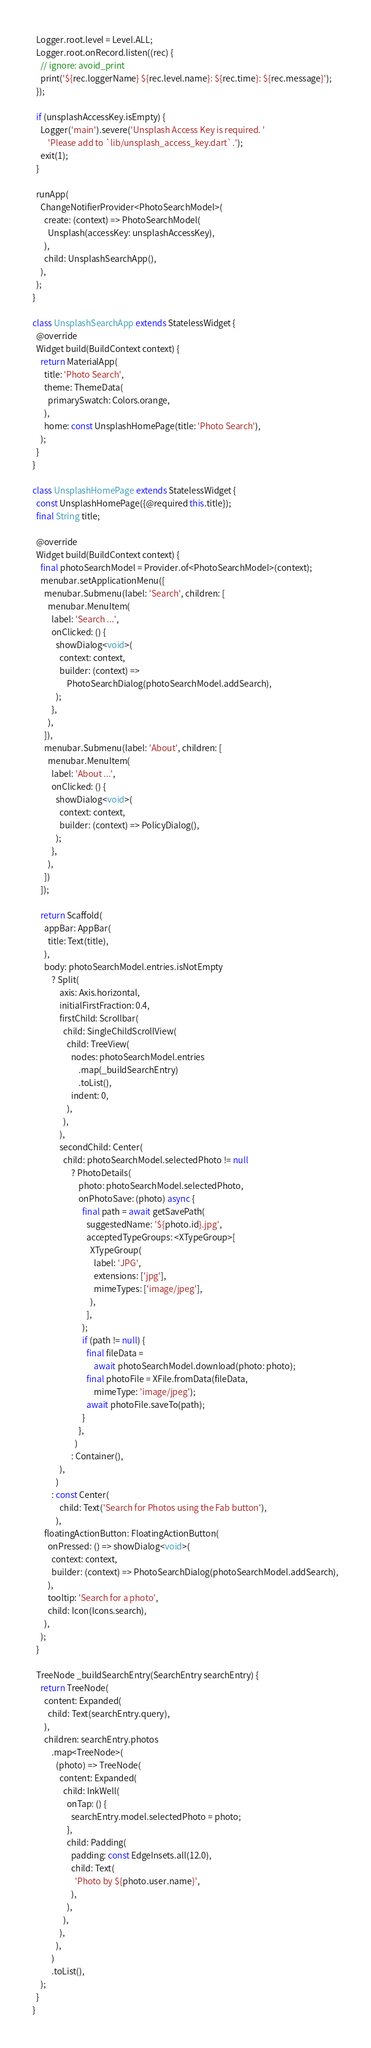<code> <loc_0><loc_0><loc_500><loc_500><_Dart_>  Logger.root.level = Level.ALL;
  Logger.root.onRecord.listen((rec) {
    // ignore: avoid_print
    print('${rec.loggerName} ${rec.level.name}: ${rec.time}: ${rec.message}');
  });

  if (unsplashAccessKey.isEmpty) {
    Logger('main').severe('Unsplash Access Key is required. '
        'Please add to `lib/unsplash_access_key.dart`.');
    exit(1);
  }

  runApp(
    ChangeNotifierProvider<PhotoSearchModel>(
      create: (context) => PhotoSearchModel(
        Unsplash(accessKey: unsplashAccessKey),
      ),
      child: UnsplashSearchApp(),
    ),
  );
}

class UnsplashSearchApp extends StatelessWidget {
  @override
  Widget build(BuildContext context) {
    return MaterialApp(
      title: 'Photo Search',
      theme: ThemeData(
        primarySwatch: Colors.orange,
      ),
      home: const UnsplashHomePage(title: 'Photo Search'),
    );
  }
}

class UnsplashHomePage extends StatelessWidget {
  const UnsplashHomePage({@required this.title});
  final String title;

  @override
  Widget build(BuildContext context) {
    final photoSearchModel = Provider.of<PhotoSearchModel>(context);
    menubar.setApplicationMenu([
      menubar.Submenu(label: 'Search', children: [
        menubar.MenuItem(
          label: 'Search ...',
          onClicked: () {
            showDialog<void>(
              context: context,
              builder: (context) =>
                  PhotoSearchDialog(photoSearchModel.addSearch),
            );
          },
        ),
      ]),
      menubar.Submenu(label: 'About', children: [
        menubar.MenuItem(
          label: 'About ...',
          onClicked: () {
            showDialog<void>(
              context: context,
              builder: (context) => PolicyDialog(),
            );
          },
        ),
      ])
    ]);

    return Scaffold(
      appBar: AppBar(
        title: Text(title),
      ),
      body: photoSearchModel.entries.isNotEmpty
          ? Split(
              axis: Axis.horizontal,
              initialFirstFraction: 0.4,
              firstChild: Scrollbar(
                child: SingleChildScrollView(
                  child: TreeView(
                    nodes: photoSearchModel.entries
                        .map(_buildSearchEntry)
                        .toList(),
                    indent: 0,
                  ),
                ),
              ),
              secondChild: Center(
                child: photoSearchModel.selectedPhoto != null
                    ? PhotoDetails(
                        photo: photoSearchModel.selectedPhoto,
                        onPhotoSave: (photo) async {
                          final path = await getSavePath(
                            suggestedName: '${photo.id}.jpg',
                            acceptedTypeGroups: <XTypeGroup>[
                              XTypeGroup(
                                label: 'JPG',
                                extensions: ['jpg'],
                                mimeTypes: ['image/jpeg'],
                              ),
                            ],
                          );
                          if (path != null) {
                            final fileData =
                                await photoSearchModel.download(photo: photo);
                            final photoFile = XFile.fromData(fileData,
                                mimeType: 'image/jpeg');
                            await photoFile.saveTo(path);
                          }
                        },
                      )
                    : Container(),
              ),
            )
          : const Center(
              child: Text('Search for Photos using the Fab button'),
            ),
      floatingActionButton: FloatingActionButton(
        onPressed: () => showDialog<void>(
          context: context,
          builder: (context) => PhotoSearchDialog(photoSearchModel.addSearch),
        ),
        tooltip: 'Search for a photo',
        child: Icon(Icons.search),
      ),
    );
  }

  TreeNode _buildSearchEntry(SearchEntry searchEntry) {
    return TreeNode(
      content: Expanded(
        child: Text(searchEntry.query),
      ),
      children: searchEntry.photos
          .map<TreeNode>(
            (photo) => TreeNode(
              content: Expanded(
                child: InkWell(
                  onTap: () {
                    searchEntry.model.selectedPhoto = photo;
                  },
                  child: Padding(
                    padding: const EdgeInsets.all(12.0),
                    child: Text(
                      'Photo by ${photo.user.name}',
                    ),
                  ),
                ),
              ),
            ),
          )
          .toList(),
    );
  }
}
</code> 